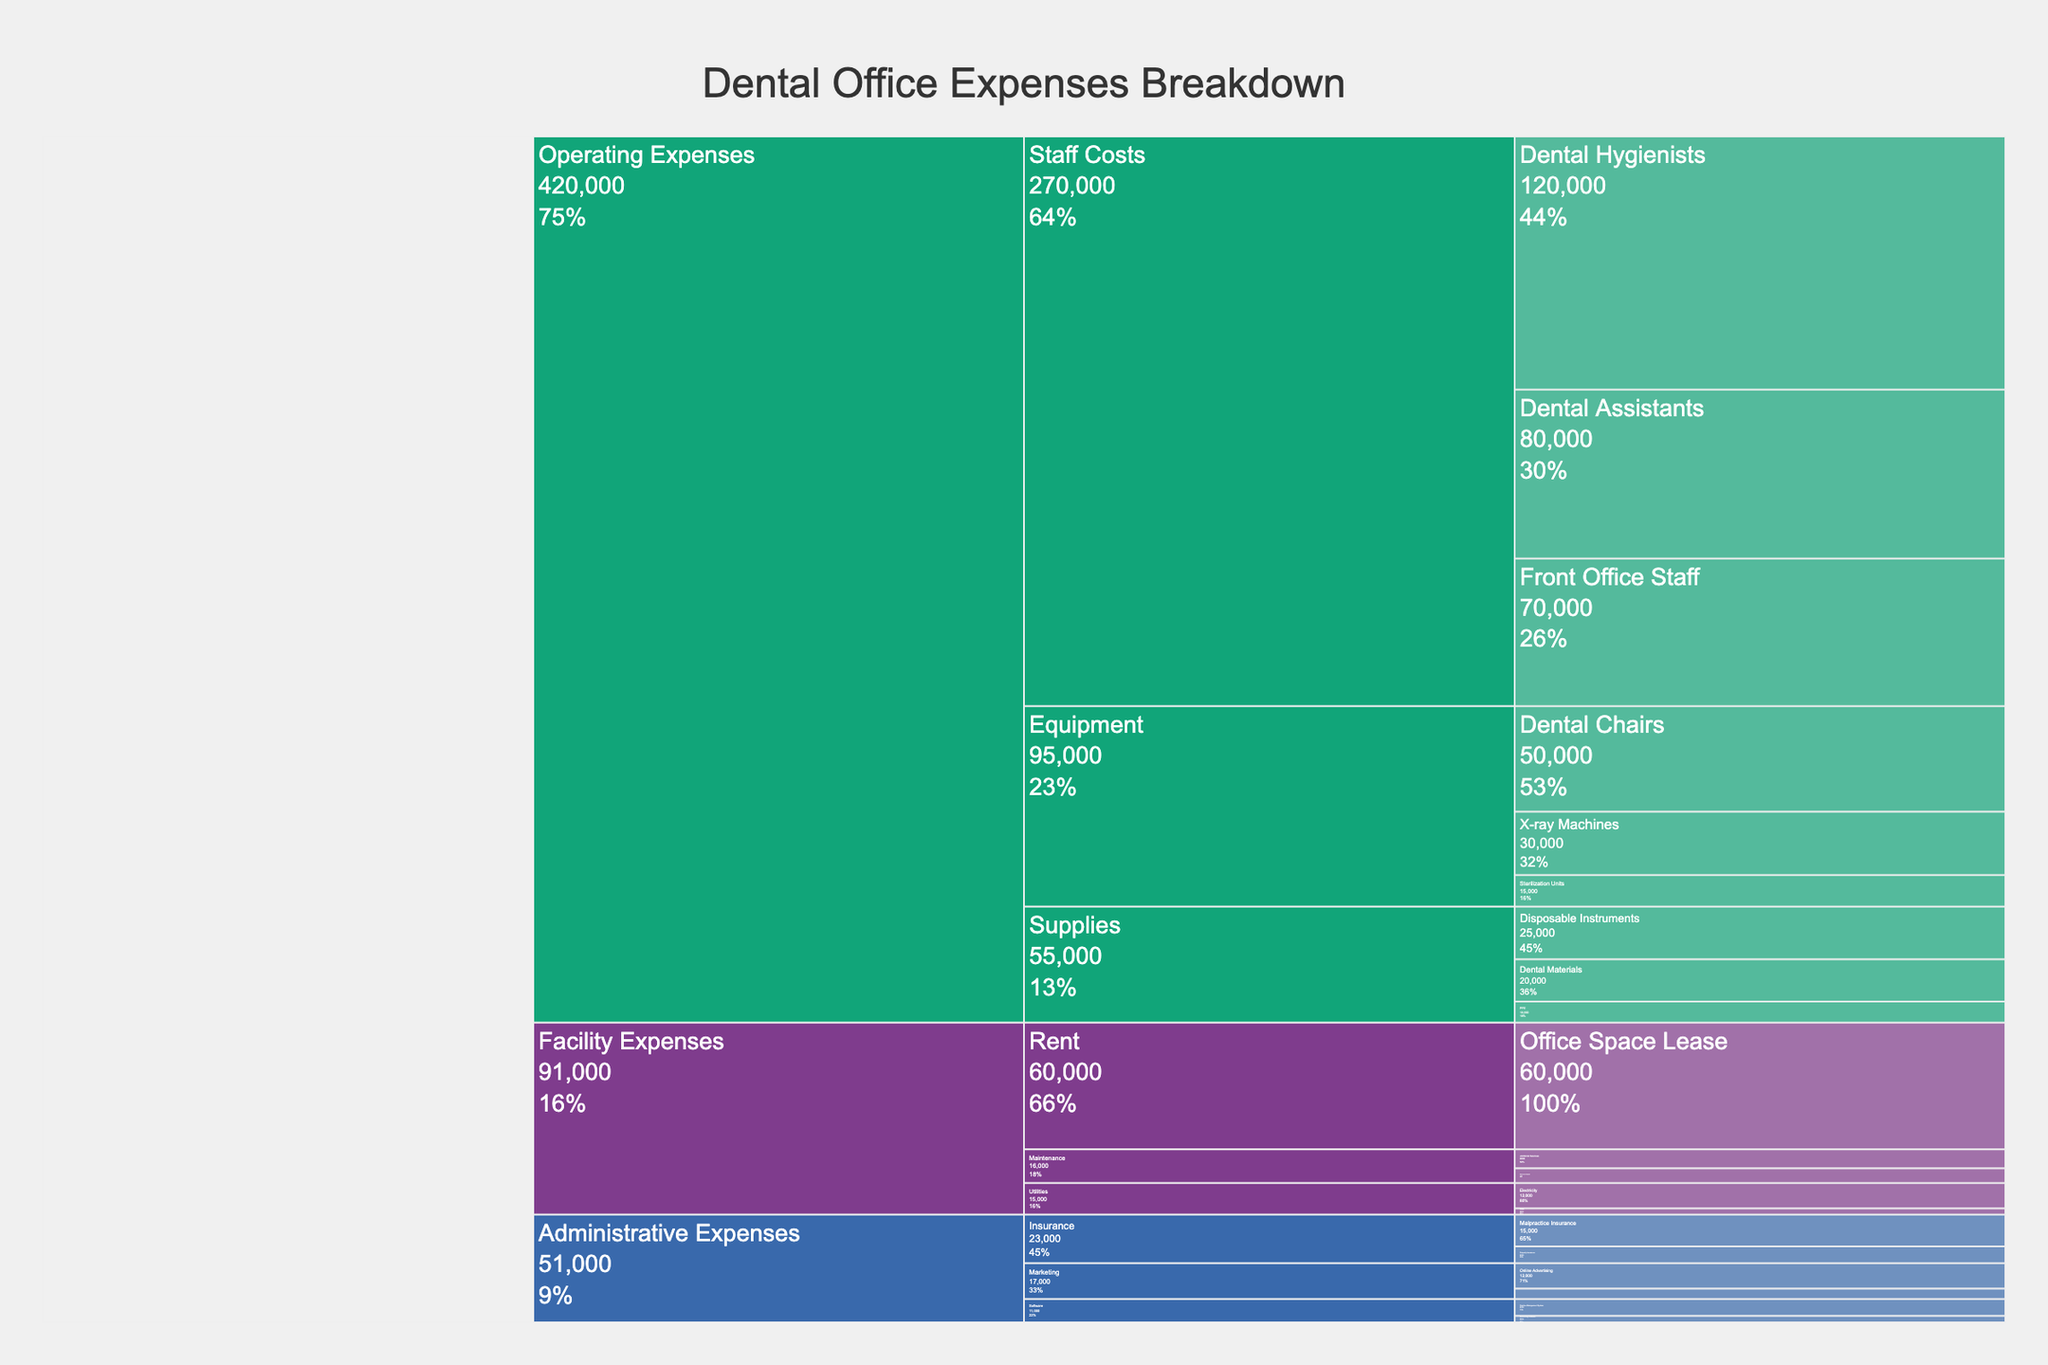What's the total expense on Staff Costs? Add the values for Dental Hygienists ($120,000), Dental Assistants ($80,000), and Front Office Staff ($70,000). The total is $120,000 + $80,000 + $70,000 = $270,000.
Answer: $270,000 Which category has the highest expense? Compare the total expenses for Operating Expenses, Administrative Expenses, and Facility Expenses. Operating Expenses has the highest, with a total of $400,000 ($270,000 on Staff Costs, $95,000 on Equipment, and $55,000 on Supplies).
Answer: Operating Expenses How much is spent on Maintenance within Facility Expenses? Add the expenses for Janitorial Services ($9,000) and Equipment Repairs ($7,000). The total is $9,000 + $7,000 = $16,000.
Answer: $16,000 What's the total expense on Insurance under Administrative Expenses? Combine the Malpractice Insurance ($15,000) and Property Insurance ($8,000). The total is $15,000 + $8,000 = $23,000.
Answer: $23,000 Which subcategory has the lowest expense in the Operating Expenses category? Compare the total values for Staff Costs, Equipment, and Supplies. Supplies is the lowest, with $25,000 (Disposable Instruments), $20,000 (Dental Materials), and $10,000 (PPE) summing to $55,000.
Answer: Supplies What percentage of Staff Costs is spent on Dental Hygienists? Divide the Dental Hygienists' cost by the total Staff Costs and multiply by 100. So, ($120,000 / $270,000) * 100% = 44.44%.
Answer: 44.44% How much more is spent on Office Space Lease than on Dental Chairs? Subtract the expense on Dental Chairs ($50,000) from the expense on Office Space Lease ($60,000). The difference is $60,000 - $50,000 = $10,000.
Answer: $10,000 What is the combined expense on Marketing and Software under Administrative Expenses? Add the expenses for Online Advertising ($12,000), Local Sponsorships ($5,000), Practice Management System ($8,000), and Accounting Software ($3,000). The total is $12,000 + $5,000 + $8,000 + $3,000 = $28,000.
Answer: $28,000 Which item has the highest expense in the Equipment subcategory? Compare Dental Chairs ($50,000), X-ray Machines ($30,000), and Sterilization Units ($15,000). Dental Chairs have the highest expense.
Answer: Dental Chairs What percentage of total Operating Expenses is spent on Supplies? Divide the total Supplies expense by the total Operating Expenses and multiply by 100. So, ($55,000 / $400,000) * 100% = 13.75%.
Answer: 13.75% 